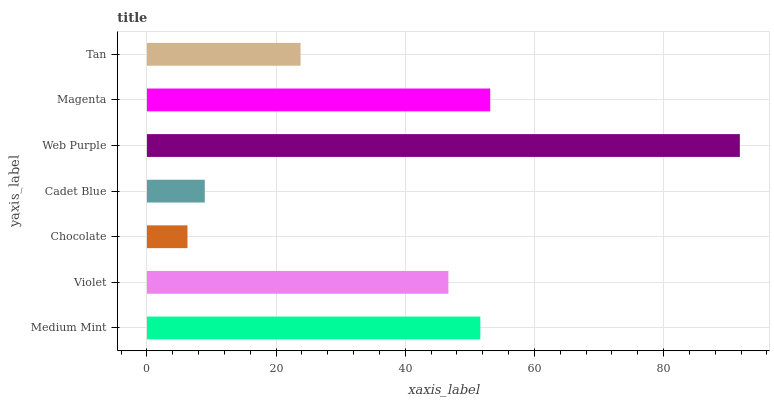Is Chocolate the minimum?
Answer yes or no. Yes. Is Web Purple the maximum?
Answer yes or no. Yes. Is Violet the minimum?
Answer yes or no. No. Is Violet the maximum?
Answer yes or no. No. Is Medium Mint greater than Violet?
Answer yes or no. Yes. Is Violet less than Medium Mint?
Answer yes or no. Yes. Is Violet greater than Medium Mint?
Answer yes or no. No. Is Medium Mint less than Violet?
Answer yes or no. No. Is Violet the high median?
Answer yes or no. Yes. Is Violet the low median?
Answer yes or no. Yes. Is Chocolate the high median?
Answer yes or no. No. Is Cadet Blue the low median?
Answer yes or no. No. 